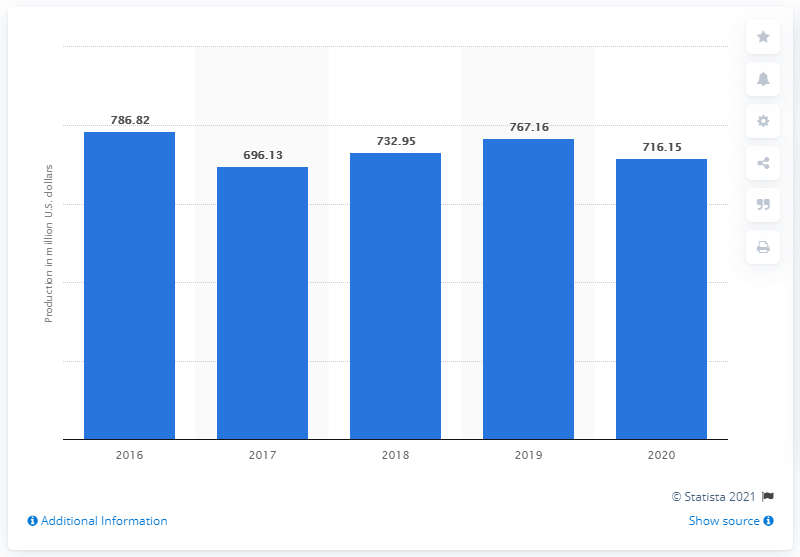Specify some key components in this picture. The production value of carrots for the fresh and processing market in the United States was 732.95 million dollars in 2018. 